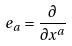Convert formula to latex. <formula><loc_0><loc_0><loc_500><loc_500>e _ { a } = \frac { \partial } { \partial x ^ { a } }</formula> 